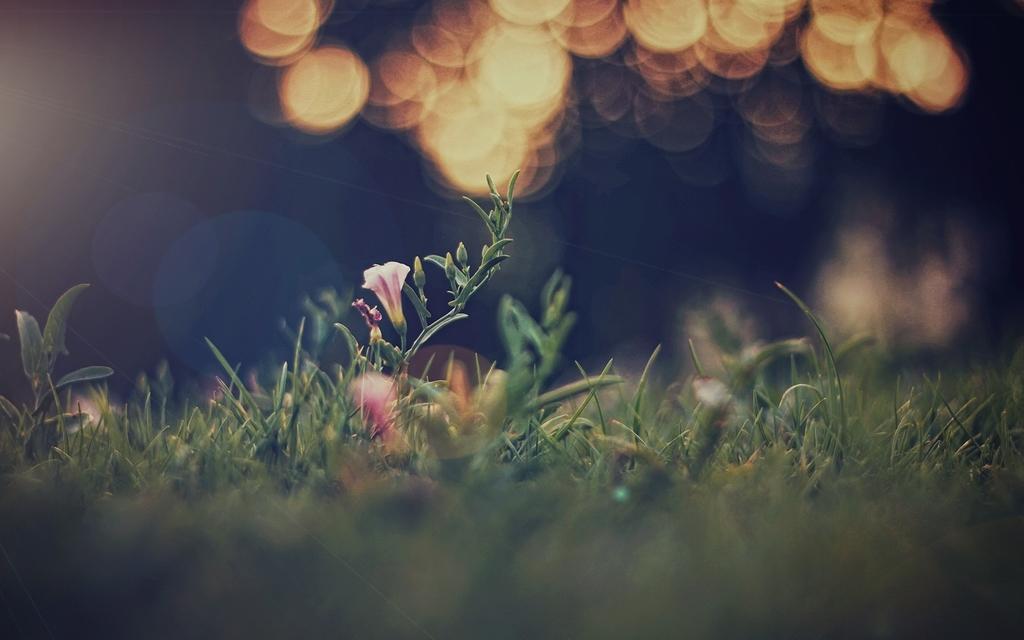Could you give a brief overview of what you see in this image? In this image I can see flowers and glass at the bottom and at the top there are few lights visible. 